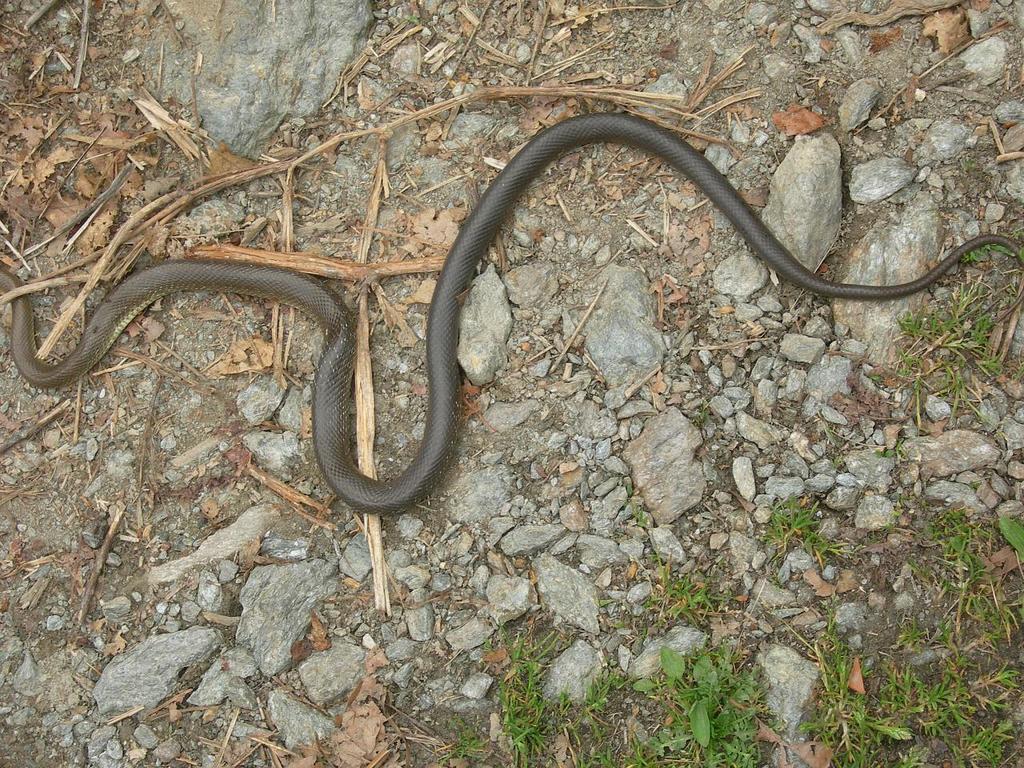In one or two sentences, can you explain what this image depicts? In this image I can see a snake on the ground. It is in black color. I can see few wooden sticks,few stones and grass. 